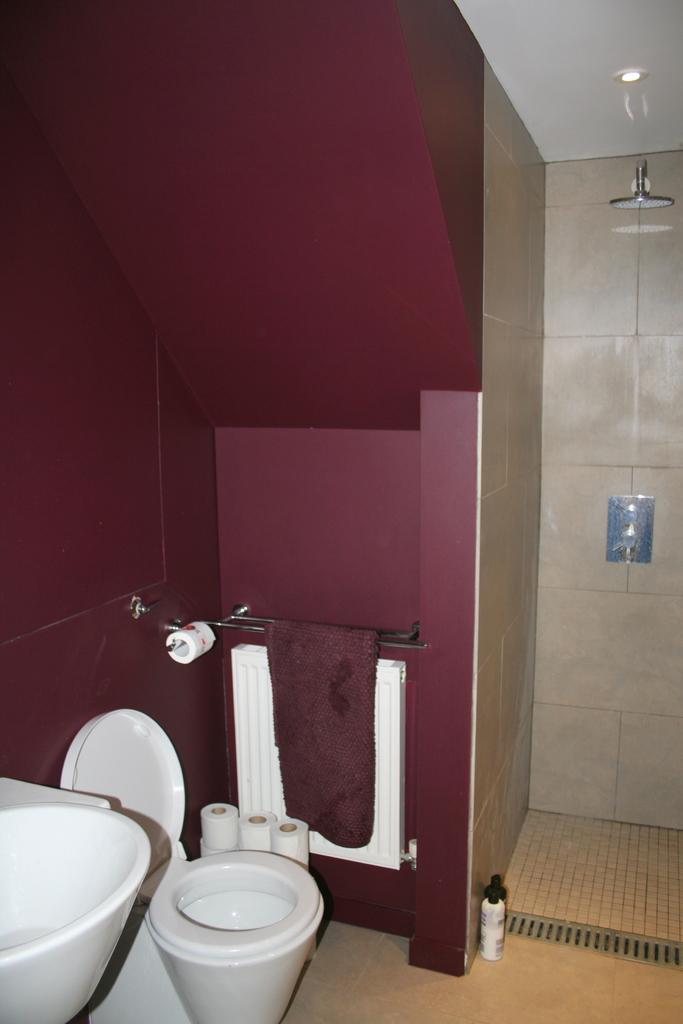How would you summarize this image in a sentence or two? In the picture I can see a toilet seat, tissue paper rolls, wall, lights on the ceiling, shower head, taps, a bottle and some other things. This is an inside view of a bathroom. 